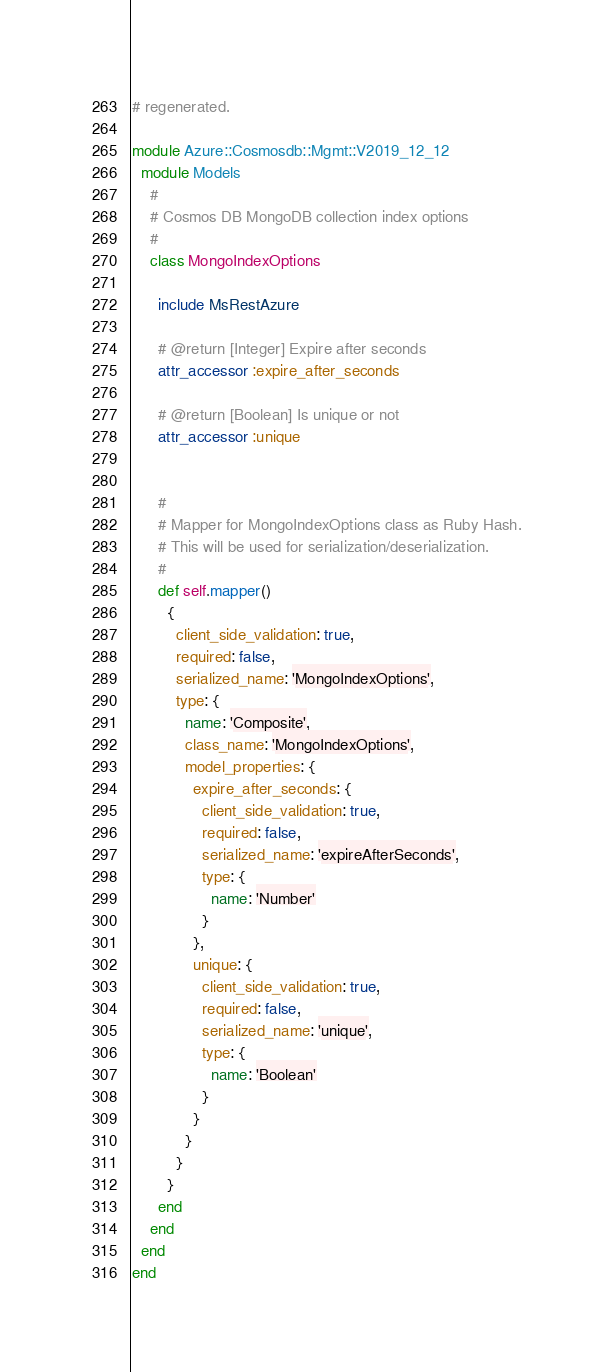Convert code to text. <code><loc_0><loc_0><loc_500><loc_500><_Ruby_># regenerated.

module Azure::Cosmosdb::Mgmt::V2019_12_12
  module Models
    #
    # Cosmos DB MongoDB collection index options
    #
    class MongoIndexOptions

      include MsRestAzure

      # @return [Integer] Expire after seconds
      attr_accessor :expire_after_seconds

      # @return [Boolean] Is unique or not
      attr_accessor :unique


      #
      # Mapper for MongoIndexOptions class as Ruby Hash.
      # This will be used for serialization/deserialization.
      #
      def self.mapper()
        {
          client_side_validation: true,
          required: false,
          serialized_name: 'MongoIndexOptions',
          type: {
            name: 'Composite',
            class_name: 'MongoIndexOptions',
            model_properties: {
              expire_after_seconds: {
                client_side_validation: true,
                required: false,
                serialized_name: 'expireAfterSeconds',
                type: {
                  name: 'Number'
                }
              },
              unique: {
                client_side_validation: true,
                required: false,
                serialized_name: 'unique',
                type: {
                  name: 'Boolean'
                }
              }
            }
          }
        }
      end
    end
  end
end
</code> 